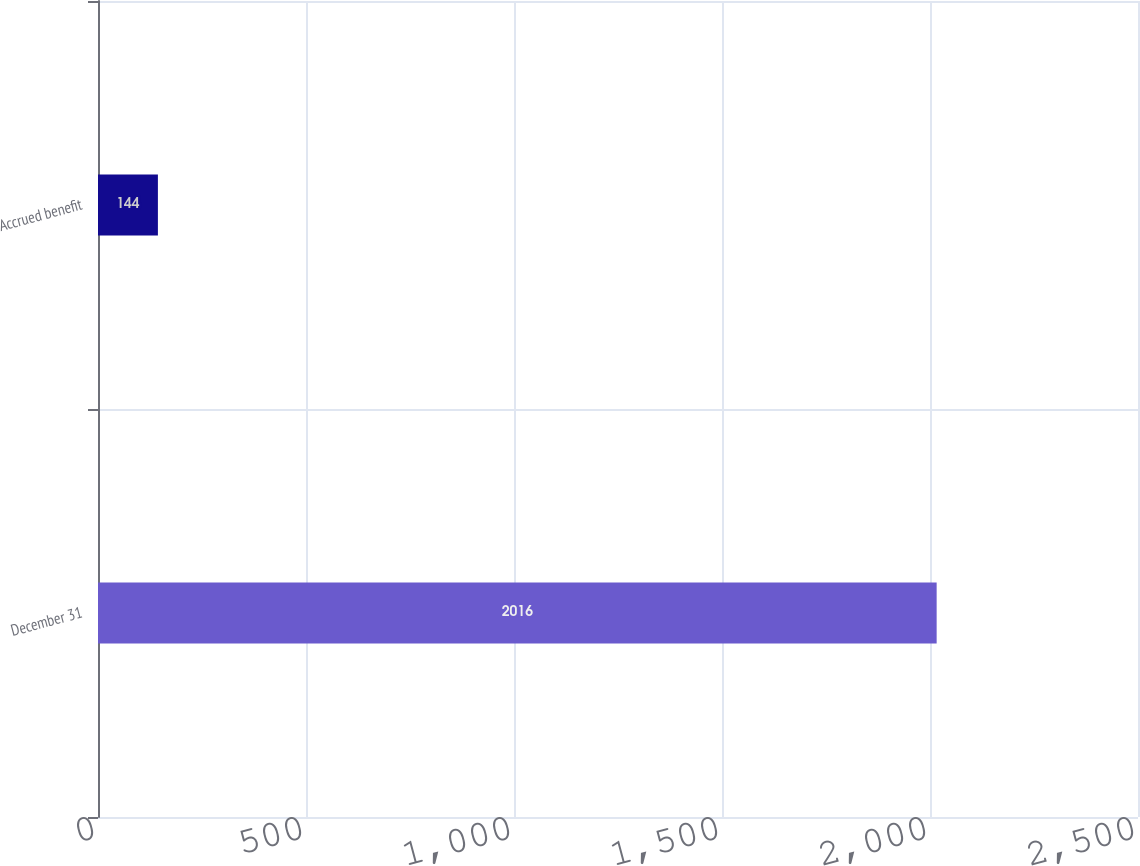Convert chart to OTSL. <chart><loc_0><loc_0><loc_500><loc_500><bar_chart><fcel>December 31<fcel>Accrued benefit<nl><fcel>2016<fcel>144<nl></chart> 